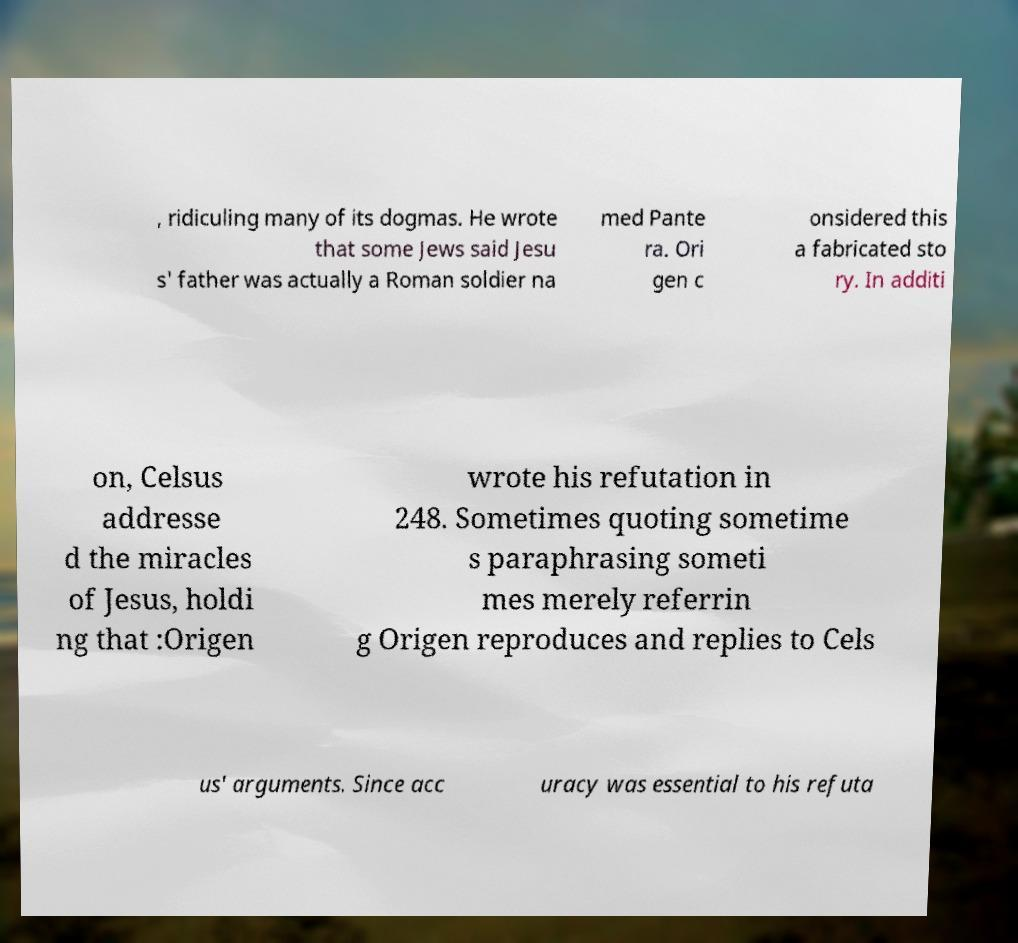What messages or text are displayed in this image? I need them in a readable, typed format. , ridiculing many of its dogmas. He wrote that some Jews said Jesu s' father was actually a Roman soldier na med Pante ra. Ori gen c onsidered this a fabricated sto ry. In additi on, Celsus addresse d the miracles of Jesus, holdi ng that :Origen wrote his refutation in 248. Sometimes quoting sometime s paraphrasing someti mes merely referrin g Origen reproduces and replies to Cels us' arguments. Since acc uracy was essential to his refuta 